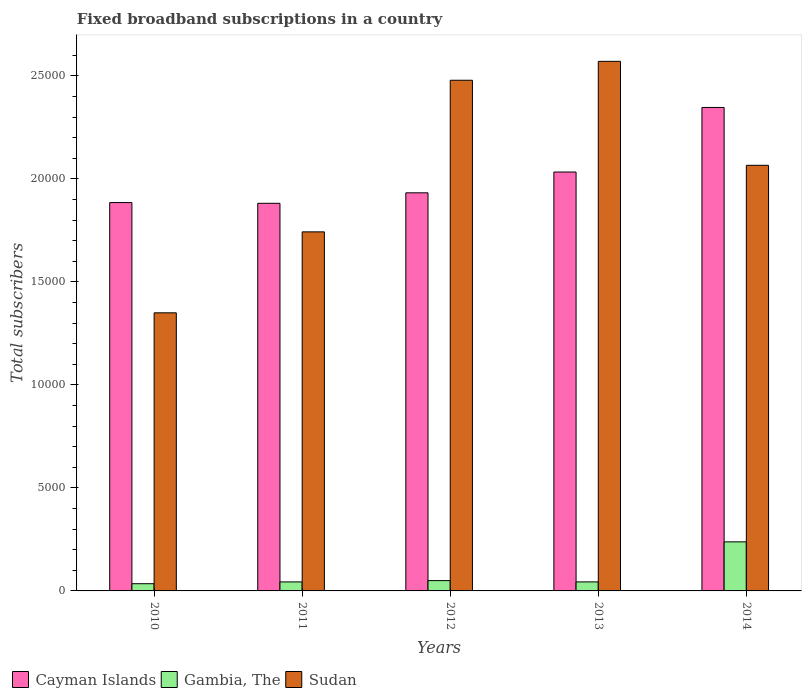Are the number of bars per tick equal to the number of legend labels?
Provide a short and direct response. Yes. What is the label of the 2nd group of bars from the left?
Offer a very short reply. 2011. What is the number of broadband subscriptions in Cayman Islands in 2014?
Provide a short and direct response. 2.35e+04. Across all years, what is the maximum number of broadband subscriptions in Sudan?
Keep it short and to the point. 2.57e+04. Across all years, what is the minimum number of broadband subscriptions in Gambia, The?
Your answer should be compact. 350. In which year was the number of broadband subscriptions in Gambia, The maximum?
Your answer should be compact. 2014. What is the total number of broadband subscriptions in Sudan in the graph?
Offer a very short reply. 1.02e+05. What is the difference between the number of broadband subscriptions in Gambia, The in 2010 and that in 2014?
Your answer should be very brief. -2032. What is the difference between the number of broadband subscriptions in Gambia, The in 2011 and the number of broadband subscriptions in Cayman Islands in 2013?
Offer a terse response. -1.99e+04. What is the average number of broadband subscriptions in Sudan per year?
Make the answer very short. 2.04e+04. In the year 2010, what is the difference between the number of broadband subscriptions in Sudan and number of broadband subscriptions in Gambia, The?
Provide a short and direct response. 1.32e+04. What is the ratio of the number of broadband subscriptions in Sudan in 2010 to that in 2011?
Your answer should be very brief. 0.77. What is the difference between the highest and the second highest number of broadband subscriptions in Gambia, The?
Your answer should be very brief. 1882. What is the difference between the highest and the lowest number of broadband subscriptions in Cayman Islands?
Offer a terse response. 4653. In how many years, is the number of broadband subscriptions in Sudan greater than the average number of broadband subscriptions in Sudan taken over all years?
Ensure brevity in your answer.  3. What does the 3rd bar from the left in 2013 represents?
Make the answer very short. Sudan. What does the 1st bar from the right in 2011 represents?
Offer a very short reply. Sudan. Is it the case that in every year, the sum of the number of broadband subscriptions in Cayman Islands and number of broadband subscriptions in Sudan is greater than the number of broadband subscriptions in Gambia, The?
Offer a very short reply. Yes. How many bars are there?
Give a very brief answer. 15. Are all the bars in the graph horizontal?
Provide a short and direct response. No. What is the difference between two consecutive major ticks on the Y-axis?
Offer a very short reply. 5000. Are the values on the major ticks of Y-axis written in scientific E-notation?
Your response must be concise. No. Does the graph contain any zero values?
Give a very brief answer. No. Does the graph contain grids?
Your answer should be compact. No. What is the title of the graph?
Offer a very short reply. Fixed broadband subscriptions in a country. Does "Equatorial Guinea" appear as one of the legend labels in the graph?
Give a very brief answer. No. What is the label or title of the X-axis?
Provide a succinct answer. Years. What is the label or title of the Y-axis?
Your response must be concise. Total subscribers. What is the Total subscribers of Cayman Islands in 2010?
Provide a succinct answer. 1.89e+04. What is the Total subscribers of Gambia, The in 2010?
Provide a succinct answer. 350. What is the Total subscribers in Sudan in 2010?
Your answer should be compact. 1.35e+04. What is the Total subscribers of Cayman Islands in 2011?
Ensure brevity in your answer.  1.88e+04. What is the Total subscribers of Gambia, The in 2011?
Provide a succinct answer. 437. What is the Total subscribers in Sudan in 2011?
Offer a very short reply. 1.74e+04. What is the Total subscribers in Cayman Islands in 2012?
Offer a terse response. 1.93e+04. What is the Total subscribers in Gambia, The in 2012?
Your answer should be compact. 500. What is the Total subscribers in Sudan in 2012?
Your response must be concise. 2.48e+04. What is the Total subscribers of Cayman Islands in 2013?
Make the answer very short. 2.03e+04. What is the Total subscribers in Gambia, The in 2013?
Ensure brevity in your answer.  438. What is the Total subscribers in Sudan in 2013?
Offer a terse response. 2.57e+04. What is the Total subscribers of Cayman Islands in 2014?
Provide a succinct answer. 2.35e+04. What is the Total subscribers in Gambia, The in 2014?
Provide a succinct answer. 2382. What is the Total subscribers in Sudan in 2014?
Ensure brevity in your answer.  2.07e+04. Across all years, what is the maximum Total subscribers of Cayman Islands?
Your answer should be compact. 2.35e+04. Across all years, what is the maximum Total subscribers in Gambia, The?
Make the answer very short. 2382. Across all years, what is the maximum Total subscribers of Sudan?
Offer a terse response. 2.57e+04. Across all years, what is the minimum Total subscribers in Cayman Islands?
Provide a short and direct response. 1.88e+04. Across all years, what is the minimum Total subscribers of Gambia, The?
Offer a very short reply. 350. Across all years, what is the minimum Total subscribers of Sudan?
Give a very brief answer. 1.35e+04. What is the total Total subscribers in Cayman Islands in the graph?
Provide a succinct answer. 1.01e+05. What is the total Total subscribers in Gambia, The in the graph?
Provide a succinct answer. 4107. What is the total Total subscribers in Sudan in the graph?
Your response must be concise. 1.02e+05. What is the difference between the Total subscribers in Gambia, The in 2010 and that in 2011?
Your answer should be compact. -87. What is the difference between the Total subscribers of Sudan in 2010 and that in 2011?
Ensure brevity in your answer.  -3930. What is the difference between the Total subscribers of Cayman Islands in 2010 and that in 2012?
Give a very brief answer. -473. What is the difference between the Total subscribers in Gambia, The in 2010 and that in 2012?
Ensure brevity in your answer.  -150. What is the difference between the Total subscribers of Sudan in 2010 and that in 2012?
Your answer should be very brief. -1.13e+04. What is the difference between the Total subscribers of Cayman Islands in 2010 and that in 2013?
Ensure brevity in your answer.  -1483. What is the difference between the Total subscribers of Gambia, The in 2010 and that in 2013?
Ensure brevity in your answer.  -88. What is the difference between the Total subscribers of Sudan in 2010 and that in 2013?
Make the answer very short. -1.22e+04. What is the difference between the Total subscribers of Cayman Islands in 2010 and that in 2014?
Your answer should be compact. -4617. What is the difference between the Total subscribers of Gambia, The in 2010 and that in 2014?
Your answer should be compact. -2032. What is the difference between the Total subscribers of Sudan in 2010 and that in 2014?
Your answer should be compact. -7161. What is the difference between the Total subscribers of Cayman Islands in 2011 and that in 2012?
Ensure brevity in your answer.  -509. What is the difference between the Total subscribers of Gambia, The in 2011 and that in 2012?
Offer a terse response. -63. What is the difference between the Total subscribers in Sudan in 2011 and that in 2012?
Your answer should be very brief. -7359. What is the difference between the Total subscribers in Cayman Islands in 2011 and that in 2013?
Your response must be concise. -1519. What is the difference between the Total subscribers of Sudan in 2011 and that in 2013?
Make the answer very short. -8277. What is the difference between the Total subscribers in Cayman Islands in 2011 and that in 2014?
Your response must be concise. -4653. What is the difference between the Total subscribers in Gambia, The in 2011 and that in 2014?
Give a very brief answer. -1945. What is the difference between the Total subscribers in Sudan in 2011 and that in 2014?
Ensure brevity in your answer.  -3231. What is the difference between the Total subscribers in Cayman Islands in 2012 and that in 2013?
Your response must be concise. -1010. What is the difference between the Total subscribers in Sudan in 2012 and that in 2013?
Provide a short and direct response. -918. What is the difference between the Total subscribers of Cayman Islands in 2012 and that in 2014?
Provide a succinct answer. -4144. What is the difference between the Total subscribers in Gambia, The in 2012 and that in 2014?
Your answer should be very brief. -1882. What is the difference between the Total subscribers of Sudan in 2012 and that in 2014?
Your response must be concise. 4128. What is the difference between the Total subscribers of Cayman Islands in 2013 and that in 2014?
Provide a short and direct response. -3134. What is the difference between the Total subscribers in Gambia, The in 2013 and that in 2014?
Keep it short and to the point. -1944. What is the difference between the Total subscribers in Sudan in 2013 and that in 2014?
Ensure brevity in your answer.  5046. What is the difference between the Total subscribers in Cayman Islands in 2010 and the Total subscribers in Gambia, The in 2011?
Offer a terse response. 1.84e+04. What is the difference between the Total subscribers of Cayman Islands in 2010 and the Total subscribers of Sudan in 2011?
Your answer should be very brief. 1422. What is the difference between the Total subscribers in Gambia, The in 2010 and the Total subscribers in Sudan in 2011?
Offer a very short reply. -1.71e+04. What is the difference between the Total subscribers of Cayman Islands in 2010 and the Total subscribers of Gambia, The in 2012?
Ensure brevity in your answer.  1.84e+04. What is the difference between the Total subscribers of Cayman Islands in 2010 and the Total subscribers of Sudan in 2012?
Ensure brevity in your answer.  -5937. What is the difference between the Total subscribers of Gambia, The in 2010 and the Total subscribers of Sudan in 2012?
Offer a very short reply. -2.44e+04. What is the difference between the Total subscribers of Cayman Islands in 2010 and the Total subscribers of Gambia, The in 2013?
Offer a very short reply. 1.84e+04. What is the difference between the Total subscribers of Cayman Islands in 2010 and the Total subscribers of Sudan in 2013?
Your response must be concise. -6855. What is the difference between the Total subscribers of Gambia, The in 2010 and the Total subscribers of Sudan in 2013?
Your response must be concise. -2.54e+04. What is the difference between the Total subscribers in Cayman Islands in 2010 and the Total subscribers in Gambia, The in 2014?
Give a very brief answer. 1.65e+04. What is the difference between the Total subscribers in Cayman Islands in 2010 and the Total subscribers in Sudan in 2014?
Provide a short and direct response. -1809. What is the difference between the Total subscribers of Gambia, The in 2010 and the Total subscribers of Sudan in 2014?
Your answer should be very brief. -2.03e+04. What is the difference between the Total subscribers of Cayman Islands in 2011 and the Total subscribers of Gambia, The in 2012?
Ensure brevity in your answer.  1.83e+04. What is the difference between the Total subscribers in Cayman Islands in 2011 and the Total subscribers in Sudan in 2012?
Provide a short and direct response. -5973. What is the difference between the Total subscribers in Gambia, The in 2011 and the Total subscribers in Sudan in 2012?
Offer a very short reply. -2.44e+04. What is the difference between the Total subscribers of Cayman Islands in 2011 and the Total subscribers of Gambia, The in 2013?
Keep it short and to the point. 1.84e+04. What is the difference between the Total subscribers of Cayman Islands in 2011 and the Total subscribers of Sudan in 2013?
Your response must be concise. -6891. What is the difference between the Total subscribers in Gambia, The in 2011 and the Total subscribers in Sudan in 2013?
Provide a succinct answer. -2.53e+04. What is the difference between the Total subscribers in Cayman Islands in 2011 and the Total subscribers in Gambia, The in 2014?
Make the answer very short. 1.64e+04. What is the difference between the Total subscribers in Cayman Islands in 2011 and the Total subscribers in Sudan in 2014?
Keep it short and to the point. -1845. What is the difference between the Total subscribers in Gambia, The in 2011 and the Total subscribers in Sudan in 2014?
Give a very brief answer. -2.02e+04. What is the difference between the Total subscribers in Cayman Islands in 2012 and the Total subscribers in Gambia, The in 2013?
Give a very brief answer. 1.89e+04. What is the difference between the Total subscribers of Cayman Islands in 2012 and the Total subscribers of Sudan in 2013?
Provide a short and direct response. -6382. What is the difference between the Total subscribers in Gambia, The in 2012 and the Total subscribers in Sudan in 2013?
Ensure brevity in your answer.  -2.52e+04. What is the difference between the Total subscribers of Cayman Islands in 2012 and the Total subscribers of Gambia, The in 2014?
Offer a terse response. 1.69e+04. What is the difference between the Total subscribers of Cayman Islands in 2012 and the Total subscribers of Sudan in 2014?
Make the answer very short. -1336. What is the difference between the Total subscribers of Gambia, The in 2012 and the Total subscribers of Sudan in 2014?
Ensure brevity in your answer.  -2.02e+04. What is the difference between the Total subscribers of Cayman Islands in 2013 and the Total subscribers of Gambia, The in 2014?
Provide a succinct answer. 1.80e+04. What is the difference between the Total subscribers in Cayman Islands in 2013 and the Total subscribers in Sudan in 2014?
Give a very brief answer. -326. What is the difference between the Total subscribers of Gambia, The in 2013 and the Total subscribers of Sudan in 2014?
Give a very brief answer. -2.02e+04. What is the average Total subscribers in Cayman Islands per year?
Your response must be concise. 2.02e+04. What is the average Total subscribers of Gambia, The per year?
Provide a succinct answer. 821.4. What is the average Total subscribers in Sudan per year?
Give a very brief answer. 2.04e+04. In the year 2010, what is the difference between the Total subscribers in Cayman Islands and Total subscribers in Gambia, The?
Your answer should be very brief. 1.85e+04. In the year 2010, what is the difference between the Total subscribers of Cayman Islands and Total subscribers of Sudan?
Offer a very short reply. 5352. In the year 2010, what is the difference between the Total subscribers in Gambia, The and Total subscribers in Sudan?
Provide a short and direct response. -1.32e+04. In the year 2011, what is the difference between the Total subscribers in Cayman Islands and Total subscribers in Gambia, The?
Provide a succinct answer. 1.84e+04. In the year 2011, what is the difference between the Total subscribers of Cayman Islands and Total subscribers of Sudan?
Provide a short and direct response. 1386. In the year 2011, what is the difference between the Total subscribers in Gambia, The and Total subscribers in Sudan?
Ensure brevity in your answer.  -1.70e+04. In the year 2012, what is the difference between the Total subscribers in Cayman Islands and Total subscribers in Gambia, The?
Make the answer very short. 1.88e+04. In the year 2012, what is the difference between the Total subscribers in Cayman Islands and Total subscribers in Sudan?
Your answer should be very brief. -5464. In the year 2012, what is the difference between the Total subscribers in Gambia, The and Total subscribers in Sudan?
Ensure brevity in your answer.  -2.43e+04. In the year 2013, what is the difference between the Total subscribers of Cayman Islands and Total subscribers of Gambia, The?
Provide a short and direct response. 1.99e+04. In the year 2013, what is the difference between the Total subscribers in Cayman Islands and Total subscribers in Sudan?
Your answer should be very brief. -5372. In the year 2013, what is the difference between the Total subscribers of Gambia, The and Total subscribers of Sudan?
Ensure brevity in your answer.  -2.53e+04. In the year 2014, what is the difference between the Total subscribers in Cayman Islands and Total subscribers in Gambia, The?
Provide a short and direct response. 2.11e+04. In the year 2014, what is the difference between the Total subscribers of Cayman Islands and Total subscribers of Sudan?
Your answer should be very brief. 2808. In the year 2014, what is the difference between the Total subscribers of Gambia, The and Total subscribers of Sudan?
Your answer should be very brief. -1.83e+04. What is the ratio of the Total subscribers of Gambia, The in 2010 to that in 2011?
Provide a short and direct response. 0.8. What is the ratio of the Total subscribers in Sudan in 2010 to that in 2011?
Keep it short and to the point. 0.77. What is the ratio of the Total subscribers in Cayman Islands in 2010 to that in 2012?
Provide a short and direct response. 0.98. What is the ratio of the Total subscribers in Gambia, The in 2010 to that in 2012?
Offer a terse response. 0.7. What is the ratio of the Total subscribers in Sudan in 2010 to that in 2012?
Your response must be concise. 0.54. What is the ratio of the Total subscribers of Cayman Islands in 2010 to that in 2013?
Give a very brief answer. 0.93. What is the ratio of the Total subscribers of Gambia, The in 2010 to that in 2013?
Offer a terse response. 0.8. What is the ratio of the Total subscribers of Sudan in 2010 to that in 2013?
Give a very brief answer. 0.53. What is the ratio of the Total subscribers of Cayman Islands in 2010 to that in 2014?
Offer a terse response. 0.8. What is the ratio of the Total subscribers of Gambia, The in 2010 to that in 2014?
Offer a very short reply. 0.15. What is the ratio of the Total subscribers of Sudan in 2010 to that in 2014?
Your answer should be compact. 0.65. What is the ratio of the Total subscribers of Cayman Islands in 2011 to that in 2012?
Provide a succinct answer. 0.97. What is the ratio of the Total subscribers of Gambia, The in 2011 to that in 2012?
Your answer should be very brief. 0.87. What is the ratio of the Total subscribers of Sudan in 2011 to that in 2012?
Provide a succinct answer. 0.7. What is the ratio of the Total subscribers in Cayman Islands in 2011 to that in 2013?
Offer a very short reply. 0.93. What is the ratio of the Total subscribers of Sudan in 2011 to that in 2013?
Your answer should be compact. 0.68. What is the ratio of the Total subscribers in Cayman Islands in 2011 to that in 2014?
Ensure brevity in your answer.  0.8. What is the ratio of the Total subscribers in Gambia, The in 2011 to that in 2014?
Give a very brief answer. 0.18. What is the ratio of the Total subscribers in Sudan in 2011 to that in 2014?
Offer a terse response. 0.84. What is the ratio of the Total subscribers in Cayman Islands in 2012 to that in 2013?
Ensure brevity in your answer.  0.95. What is the ratio of the Total subscribers in Gambia, The in 2012 to that in 2013?
Your response must be concise. 1.14. What is the ratio of the Total subscribers of Sudan in 2012 to that in 2013?
Ensure brevity in your answer.  0.96. What is the ratio of the Total subscribers in Cayman Islands in 2012 to that in 2014?
Your answer should be very brief. 0.82. What is the ratio of the Total subscribers in Gambia, The in 2012 to that in 2014?
Provide a short and direct response. 0.21. What is the ratio of the Total subscribers in Sudan in 2012 to that in 2014?
Offer a very short reply. 1.2. What is the ratio of the Total subscribers in Cayman Islands in 2013 to that in 2014?
Offer a very short reply. 0.87. What is the ratio of the Total subscribers in Gambia, The in 2013 to that in 2014?
Keep it short and to the point. 0.18. What is the ratio of the Total subscribers of Sudan in 2013 to that in 2014?
Your answer should be compact. 1.24. What is the difference between the highest and the second highest Total subscribers in Cayman Islands?
Your response must be concise. 3134. What is the difference between the highest and the second highest Total subscribers in Gambia, The?
Offer a very short reply. 1882. What is the difference between the highest and the second highest Total subscribers in Sudan?
Ensure brevity in your answer.  918. What is the difference between the highest and the lowest Total subscribers of Cayman Islands?
Keep it short and to the point. 4653. What is the difference between the highest and the lowest Total subscribers of Gambia, The?
Keep it short and to the point. 2032. What is the difference between the highest and the lowest Total subscribers of Sudan?
Ensure brevity in your answer.  1.22e+04. 